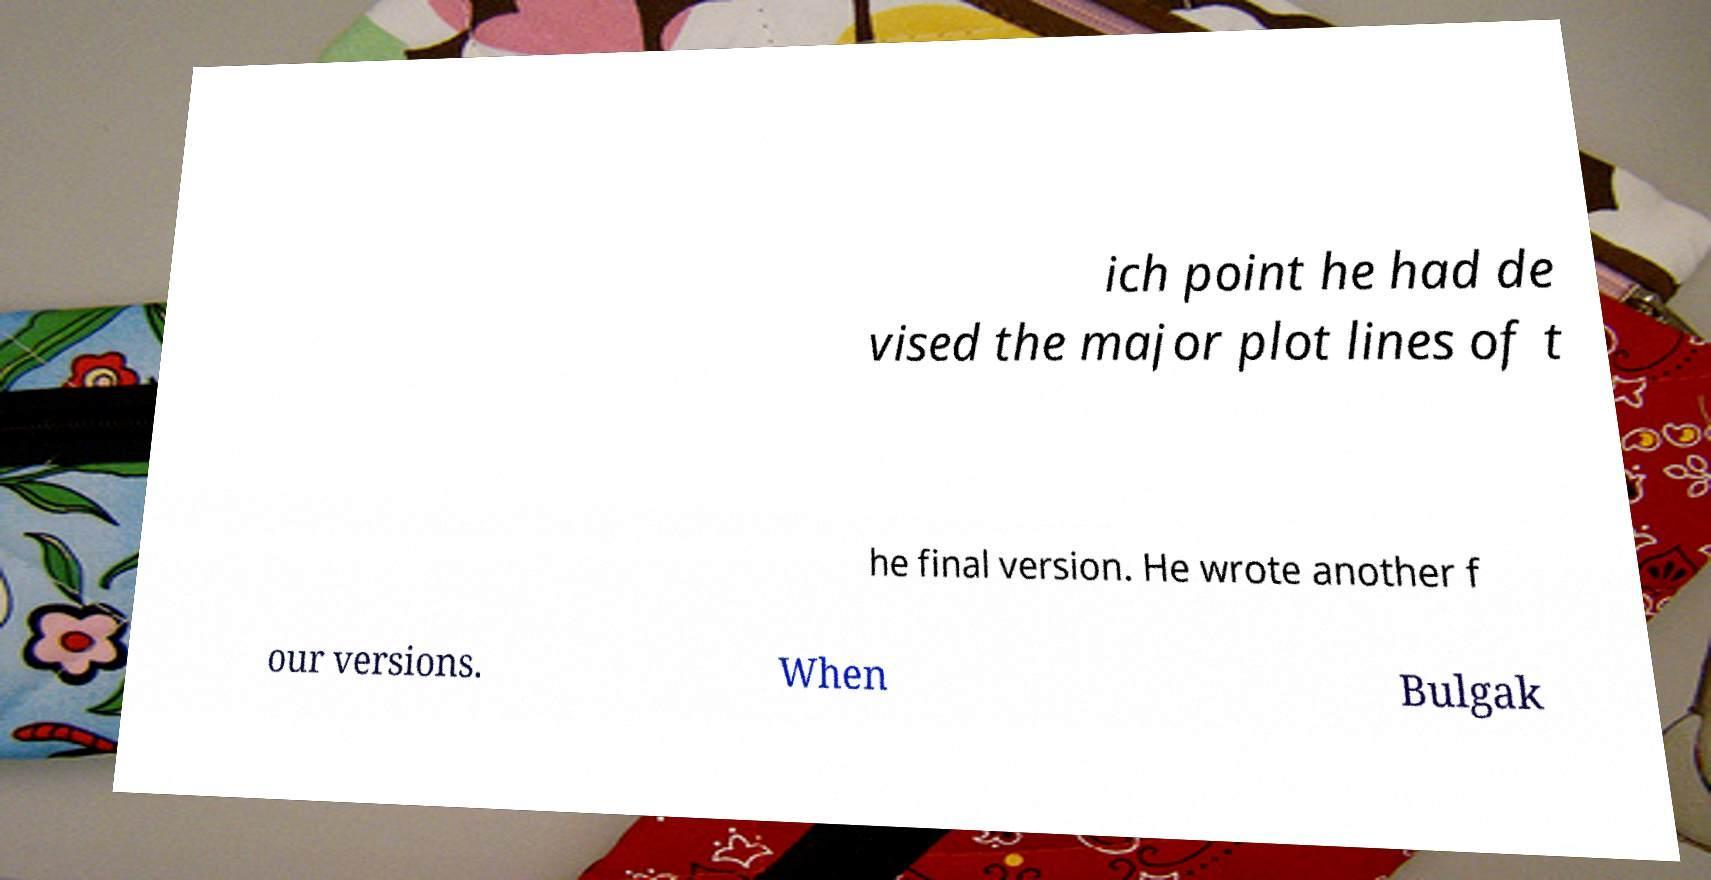Could you assist in decoding the text presented in this image and type it out clearly? ich point he had de vised the major plot lines of t he final version. He wrote another f our versions. When Bulgak 